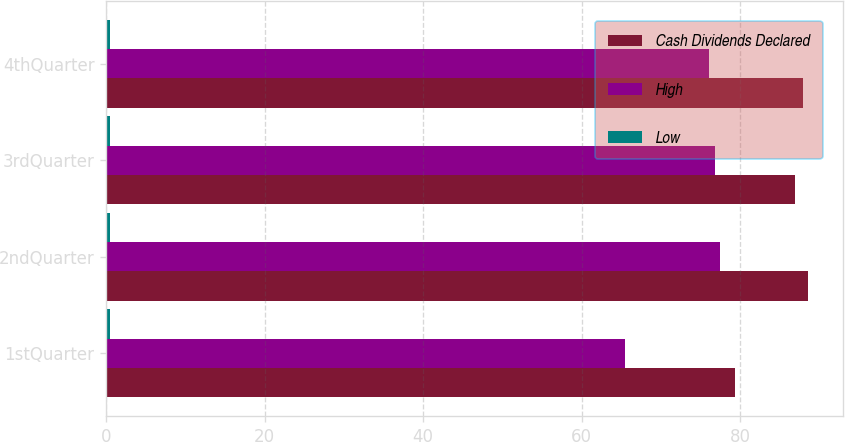Convert chart. <chart><loc_0><loc_0><loc_500><loc_500><stacked_bar_chart><ecel><fcel>1stQuarter<fcel>2ndQuarter<fcel>3rdQuarter<fcel>4thQuarter<nl><fcel>Cash Dividends Declared<fcel>79.4<fcel>88.53<fcel>87<fcel>87.96<nl><fcel>High<fcel>65.52<fcel>77.42<fcel>76.8<fcel>76.14<nl><fcel>Low<fcel>0.51<fcel>0.51<fcel>0.51<fcel>0.51<nl></chart> 